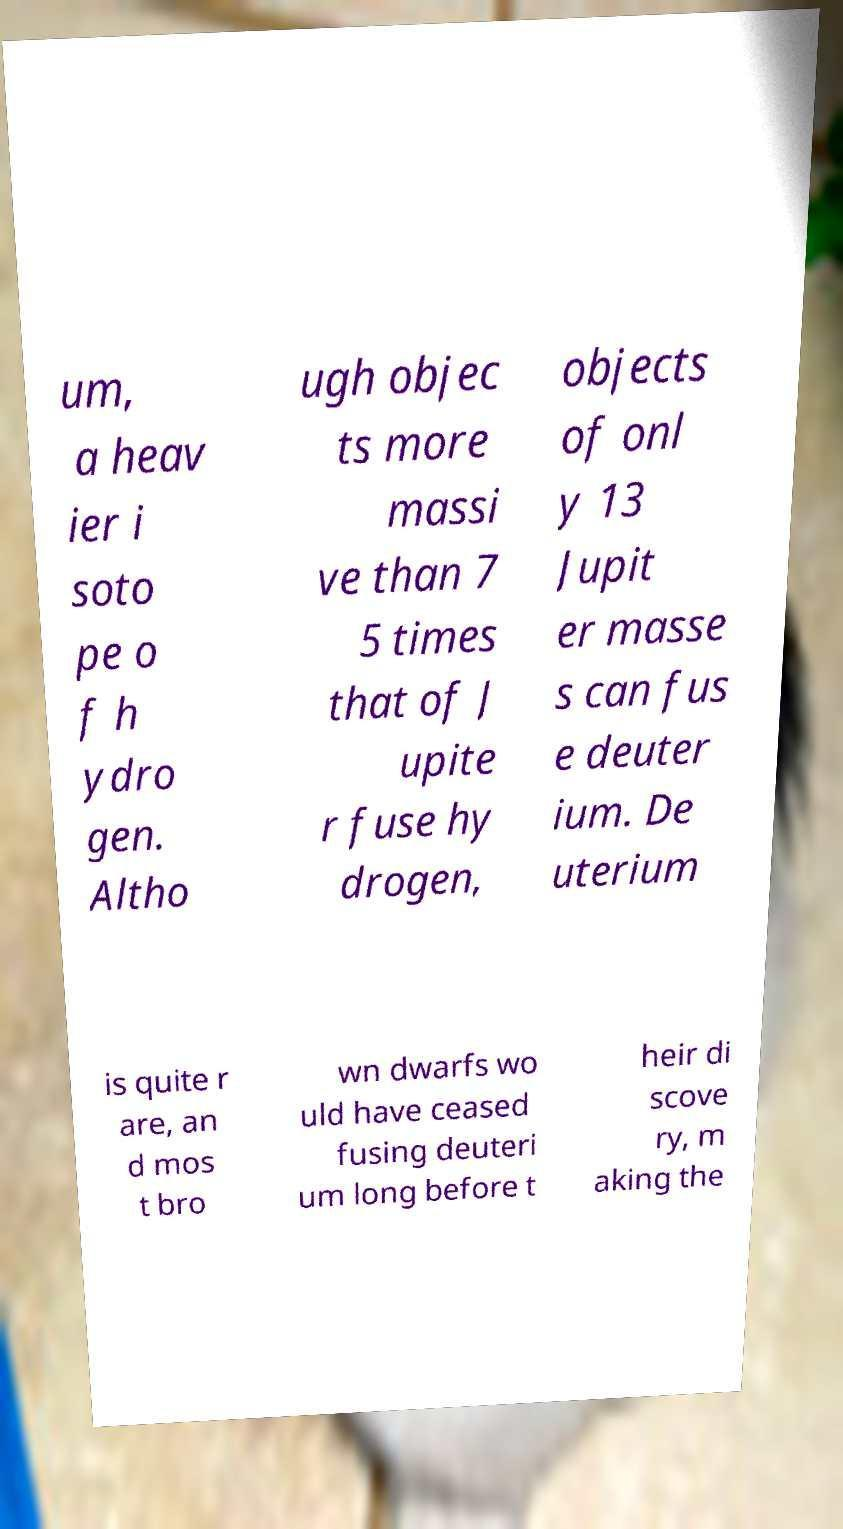Please identify and transcribe the text found in this image. um, a heav ier i soto pe o f h ydro gen. Altho ugh objec ts more massi ve than 7 5 times that of J upite r fuse hy drogen, objects of onl y 13 Jupit er masse s can fus e deuter ium. De uterium is quite r are, an d mos t bro wn dwarfs wo uld have ceased fusing deuteri um long before t heir di scove ry, m aking the 